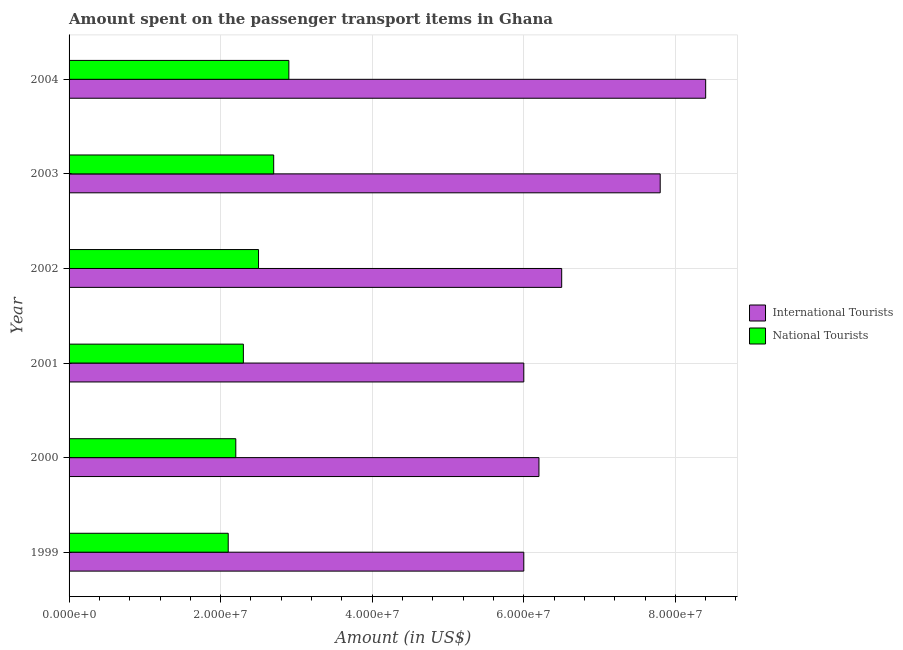How many groups of bars are there?
Offer a terse response. 6. Are the number of bars per tick equal to the number of legend labels?
Your response must be concise. Yes. Are the number of bars on each tick of the Y-axis equal?
Your answer should be very brief. Yes. What is the label of the 6th group of bars from the top?
Your response must be concise. 1999. What is the amount spent on transport items of national tourists in 2002?
Keep it short and to the point. 2.50e+07. Across all years, what is the maximum amount spent on transport items of international tourists?
Provide a succinct answer. 8.40e+07. Across all years, what is the minimum amount spent on transport items of national tourists?
Ensure brevity in your answer.  2.10e+07. What is the total amount spent on transport items of national tourists in the graph?
Offer a terse response. 1.47e+08. What is the difference between the amount spent on transport items of national tourists in 2000 and that in 2003?
Make the answer very short. -5.00e+06. What is the difference between the amount spent on transport items of international tourists in 2004 and the amount spent on transport items of national tourists in 2002?
Your answer should be very brief. 5.90e+07. What is the average amount spent on transport items of international tourists per year?
Your answer should be compact. 6.82e+07. In the year 1999, what is the difference between the amount spent on transport items of national tourists and amount spent on transport items of international tourists?
Provide a short and direct response. -3.90e+07. What is the ratio of the amount spent on transport items of national tourists in 1999 to that in 2002?
Give a very brief answer. 0.84. Is the difference between the amount spent on transport items of national tourists in 2001 and 2003 greater than the difference between the amount spent on transport items of international tourists in 2001 and 2003?
Your answer should be compact. Yes. What is the difference between the highest and the second highest amount spent on transport items of national tourists?
Give a very brief answer. 2.00e+06. What is the difference between the highest and the lowest amount spent on transport items of national tourists?
Ensure brevity in your answer.  8.00e+06. In how many years, is the amount spent on transport items of national tourists greater than the average amount spent on transport items of national tourists taken over all years?
Your response must be concise. 3. Is the sum of the amount spent on transport items of national tourists in 2000 and 2001 greater than the maximum amount spent on transport items of international tourists across all years?
Offer a terse response. No. What does the 2nd bar from the top in 2003 represents?
Keep it short and to the point. International Tourists. What does the 1st bar from the bottom in 2001 represents?
Your answer should be compact. International Tourists. Are the values on the major ticks of X-axis written in scientific E-notation?
Your response must be concise. Yes. How many legend labels are there?
Offer a terse response. 2. How are the legend labels stacked?
Provide a succinct answer. Vertical. What is the title of the graph?
Offer a terse response. Amount spent on the passenger transport items in Ghana. What is the label or title of the X-axis?
Give a very brief answer. Amount (in US$). What is the Amount (in US$) of International Tourists in 1999?
Your answer should be very brief. 6.00e+07. What is the Amount (in US$) of National Tourists in 1999?
Your response must be concise. 2.10e+07. What is the Amount (in US$) of International Tourists in 2000?
Provide a succinct answer. 6.20e+07. What is the Amount (in US$) of National Tourists in 2000?
Give a very brief answer. 2.20e+07. What is the Amount (in US$) in International Tourists in 2001?
Provide a succinct answer. 6.00e+07. What is the Amount (in US$) in National Tourists in 2001?
Your response must be concise. 2.30e+07. What is the Amount (in US$) in International Tourists in 2002?
Your answer should be compact. 6.50e+07. What is the Amount (in US$) in National Tourists in 2002?
Your response must be concise. 2.50e+07. What is the Amount (in US$) in International Tourists in 2003?
Provide a succinct answer. 7.80e+07. What is the Amount (in US$) in National Tourists in 2003?
Keep it short and to the point. 2.70e+07. What is the Amount (in US$) of International Tourists in 2004?
Give a very brief answer. 8.40e+07. What is the Amount (in US$) of National Tourists in 2004?
Offer a very short reply. 2.90e+07. Across all years, what is the maximum Amount (in US$) in International Tourists?
Offer a very short reply. 8.40e+07. Across all years, what is the maximum Amount (in US$) of National Tourists?
Your response must be concise. 2.90e+07. Across all years, what is the minimum Amount (in US$) of International Tourists?
Keep it short and to the point. 6.00e+07. Across all years, what is the minimum Amount (in US$) of National Tourists?
Your answer should be compact. 2.10e+07. What is the total Amount (in US$) of International Tourists in the graph?
Your answer should be very brief. 4.09e+08. What is the total Amount (in US$) in National Tourists in the graph?
Keep it short and to the point. 1.47e+08. What is the difference between the Amount (in US$) in International Tourists in 1999 and that in 2000?
Offer a very short reply. -2.00e+06. What is the difference between the Amount (in US$) of National Tourists in 1999 and that in 2000?
Your answer should be very brief. -1.00e+06. What is the difference between the Amount (in US$) of National Tourists in 1999 and that in 2001?
Your answer should be compact. -2.00e+06. What is the difference between the Amount (in US$) of International Tourists in 1999 and that in 2002?
Provide a short and direct response. -5.00e+06. What is the difference between the Amount (in US$) in National Tourists in 1999 and that in 2002?
Give a very brief answer. -4.00e+06. What is the difference between the Amount (in US$) in International Tourists in 1999 and that in 2003?
Keep it short and to the point. -1.80e+07. What is the difference between the Amount (in US$) in National Tourists in 1999 and that in 2003?
Offer a terse response. -6.00e+06. What is the difference between the Amount (in US$) of International Tourists in 1999 and that in 2004?
Your response must be concise. -2.40e+07. What is the difference between the Amount (in US$) in National Tourists in 1999 and that in 2004?
Make the answer very short. -8.00e+06. What is the difference between the Amount (in US$) of International Tourists in 2000 and that in 2002?
Your answer should be compact. -3.00e+06. What is the difference between the Amount (in US$) in National Tourists in 2000 and that in 2002?
Your answer should be very brief. -3.00e+06. What is the difference between the Amount (in US$) of International Tourists in 2000 and that in 2003?
Ensure brevity in your answer.  -1.60e+07. What is the difference between the Amount (in US$) of National Tourists in 2000 and that in 2003?
Your answer should be compact. -5.00e+06. What is the difference between the Amount (in US$) in International Tourists in 2000 and that in 2004?
Your response must be concise. -2.20e+07. What is the difference between the Amount (in US$) of National Tourists in 2000 and that in 2004?
Your answer should be compact. -7.00e+06. What is the difference between the Amount (in US$) in International Tourists in 2001 and that in 2002?
Ensure brevity in your answer.  -5.00e+06. What is the difference between the Amount (in US$) of International Tourists in 2001 and that in 2003?
Keep it short and to the point. -1.80e+07. What is the difference between the Amount (in US$) of National Tourists in 2001 and that in 2003?
Provide a short and direct response. -4.00e+06. What is the difference between the Amount (in US$) of International Tourists in 2001 and that in 2004?
Make the answer very short. -2.40e+07. What is the difference between the Amount (in US$) of National Tourists in 2001 and that in 2004?
Offer a terse response. -6.00e+06. What is the difference between the Amount (in US$) in International Tourists in 2002 and that in 2003?
Give a very brief answer. -1.30e+07. What is the difference between the Amount (in US$) of International Tourists in 2002 and that in 2004?
Offer a very short reply. -1.90e+07. What is the difference between the Amount (in US$) of International Tourists in 2003 and that in 2004?
Keep it short and to the point. -6.00e+06. What is the difference between the Amount (in US$) of International Tourists in 1999 and the Amount (in US$) of National Tourists in 2000?
Give a very brief answer. 3.80e+07. What is the difference between the Amount (in US$) of International Tourists in 1999 and the Amount (in US$) of National Tourists in 2001?
Give a very brief answer. 3.70e+07. What is the difference between the Amount (in US$) in International Tourists in 1999 and the Amount (in US$) in National Tourists in 2002?
Your answer should be compact. 3.50e+07. What is the difference between the Amount (in US$) of International Tourists in 1999 and the Amount (in US$) of National Tourists in 2003?
Provide a succinct answer. 3.30e+07. What is the difference between the Amount (in US$) in International Tourists in 1999 and the Amount (in US$) in National Tourists in 2004?
Provide a succinct answer. 3.10e+07. What is the difference between the Amount (in US$) in International Tourists in 2000 and the Amount (in US$) in National Tourists in 2001?
Your answer should be very brief. 3.90e+07. What is the difference between the Amount (in US$) in International Tourists in 2000 and the Amount (in US$) in National Tourists in 2002?
Keep it short and to the point. 3.70e+07. What is the difference between the Amount (in US$) of International Tourists in 2000 and the Amount (in US$) of National Tourists in 2003?
Your answer should be compact. 3.50e+07. What is the difference between the Amount (in US$) in International Tourists in 2000 and the Amount (in US$) in National Tourists in 2004?
Your response must be concise. 3.30e+07. What is the difference between the Amount (in US$) in International Tourists in 2001 and the Amount (in US$) in National Tourists in 2002?
Offer a terse response. 3.50e+07. What is the difference between the Amount (in US$) in International Tourists in 2001 and the Amount (in US$) in National Tourists in 2003?
Give a very brief answer. 3.30e+07. What is the difference between the Amount (in US$) of International Tourists in 2001 and the Amount (in US$) of National Tourists in 2004?
Give a very brief answer. 3.10e+07. What is the difference between the Amount (in US$) in International Tourists in 2002 and the Amount (in US$) in National Tourists in 2003?
Provide a succinct answer. 3.80e+07. What is the difference between the Amount (in US$) in International Tourists in 2002 and the Amount (in US$) in National Tourists in 2004?
Provide a succinct answer. 3.60e+07. What is the difference between the Amount (in US$) of International Tourists in 2003 and the Amount (in US$) of National Tourists in 2004?
Offer a terse response. 4.90e+07. What is the average Amount (in US$) in International Tourists per year?
Ensure brevity in your answer.  6.82e+07. What is the average Amount (in US$) in National Tourists per year?
Make the answer very short. 2.45e+07. In the year 1999, what is the difference between the Amount (in US$) in International Tourists and Amount (in US$) in National Tourists?
Offer a very short reply. 3.90e+07. In the year 2000, what is the difference between the Amount (in US$) of International Tourists and Amount (in US$) of National Tourists?
Keep it short and to the point. 4.00e+07. In the year 2001, what is the difference between the Amount (in US$) in International Tourists and Amount (in US$) in National Tourists?
Your answer should be compact. 3.70e+07. In the year 2002, what is the difference between the Amount (in US$) of International Tourists and Amount (in US$) of National Tourists?
Provide a succinct answer. 4.00e+07. In the year 2003, what is the difference between the Amount (in US$) of International Tourists and Amount (in US$) of National Tourists?
Give a very brief answer. 5.10e+07. In the year 2004, what is the difference between the Amount (in US$) in International Tourists and Amount (in US$) in National Tourists?
Provide a short and direct response. 5.50e+07. What is the ratio of the Amount (in US$) of International Tourists in 1999 to that in 2000?
Provide a short and direct response. 0.97. What is the ratio of the Amount (in US$) of National Tourists in 1999 to that in 2000?
Give a very brief answer. 0.95. What is the ratio of the Amount (in US$) in National Tourists in 1999 to that in 2001?
Give a very brief answer. 0.91. What is the ratio of the Amount (in US$) of International Tourists in 1999 to that in 2002?
Your answer should be compact. 0.92. What is the ratio of the Amount (in US$) of National Tourists in 1999 to that in 2002?
Give a very brief answer. 0.84. What is the ratio of the Amount (in US$) of International Tourists in 1999 to that in 2003?
Keep it short and to the point. 0.77. What is the ratio of the Amount (in US$) in National Tourists in 1999 to that in 2003?
Provide a succinct answer. 0.78. What is the ratio of the Amount (in US$) of International Tourists in 1999 to that in 2004?
Your response must be concise. 0.71. What is the ratio of the Amount (in US$) in National Tourists in 1999 to that in 2004?
Your answer should be very brief. 0.72. What is the ratio of the Amount (in US$) in National Tourists in 2000 to that in 2001?
Provide a short and direct response. 0.96. What is the ratio of the Amount (in US$) in International Tourists in 2000 to that in 2002?
Make the answer very short. 0.95. What is the ratio of the Amount (in US$) of International Tourists in 2000 to that in 2003?
Your answer should be compact. 0.79. What is the ratio of the Amount (in US$) in National Tourists in 2000 to that in 2003?
Your response must be concise. 0.81. What is the ratio of the Amount (in US$) of International Tourists in 2000 to that in 2004?
Keep it short and to the point. 0.74. What is the ratio of the Amount (in US$) in National Tourists in 2000 to that in 2004?
Keep it short and to the point. 0.76. What is the ratio of the Amount (in US$) of International Tourists in 2001 to that in 2003?
Keep it short and to the point. 0.77. What is the ratio of the Amount (in US$) in National Tourists in 2001 to that in 2003?
Your response must be concise. 0.85. What is the ratio of the Amount (in US$) of National Tourists in 2001 to that in 2004?
Ensure brevity in your answer.  0.79. What is the ratio of the Amount (in US$) of National Tourists in 2002 to that in 2003?
Provide a short and direct response. 0.93. What is the ratio of the Amount (in US$) in International Tourists in 2002 to that in 2004?
Offer a very short reply. 0.77. What is the ratio of the Amount (in US$) of National Tourists in 2002 to that in 2004?
Give a very brief answer. 0.86. What is the difference between the highest and the second highest Amount (in US$) in International Tourists?
Provide a succinct answer. 6.00e+06. What is the difference between the highest and the second highest Amount (in US$) in National Tourists?
Ensure brevity in your answer.  2.00e+06. What is the difference between the highest and the lowest Amount (in US$) of International Tourists?
Provide a short and direct response. 2.40e+07. 